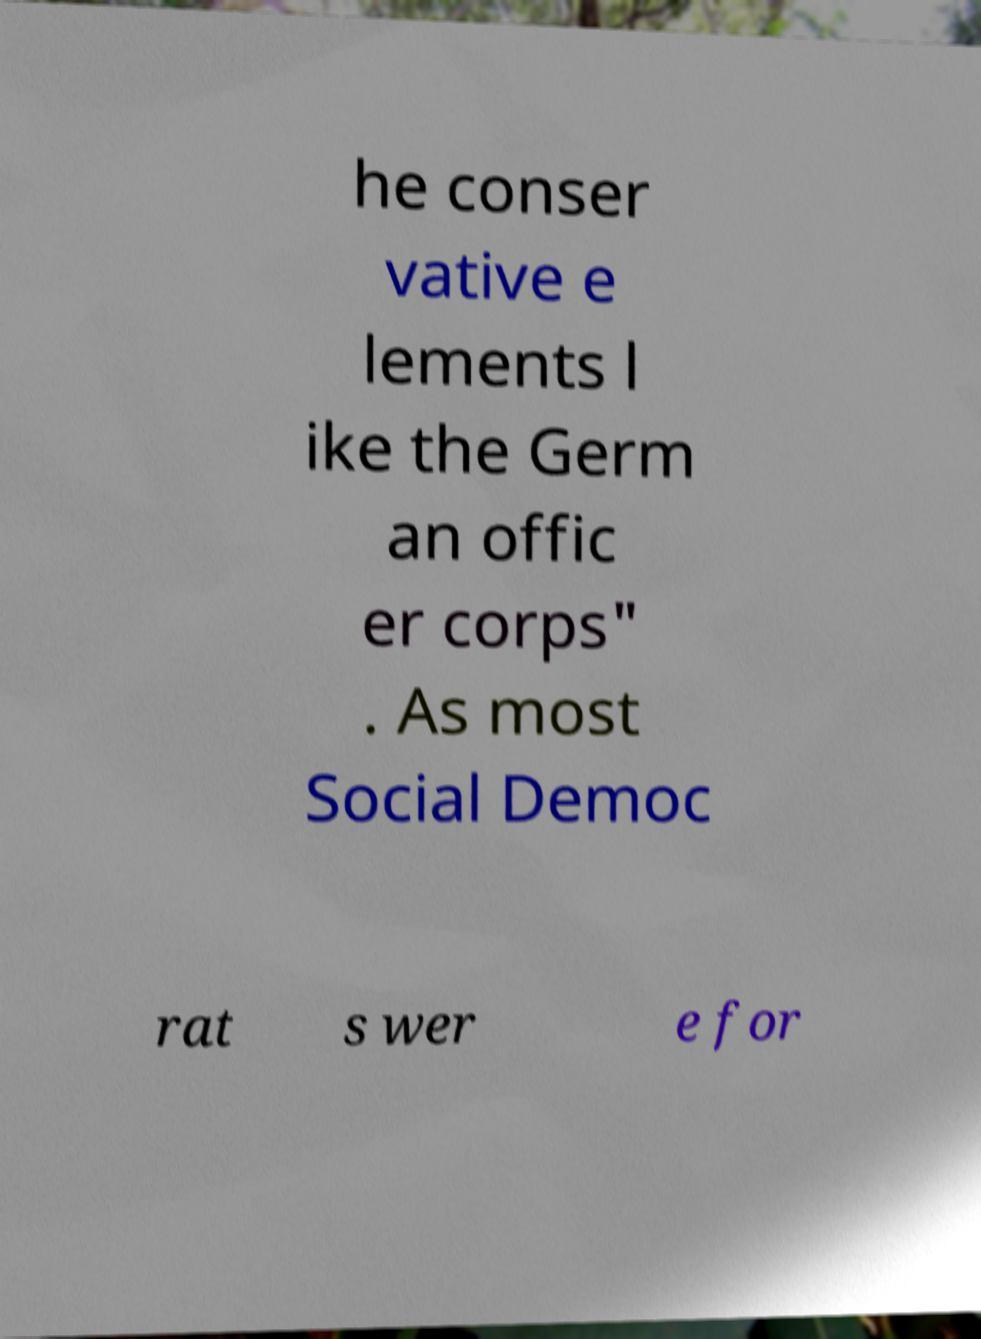Could you extract and type out the text from this image? he conser vative e lements l ike the Germ an offic er corps" . As most Social Democ rat s wer e for 